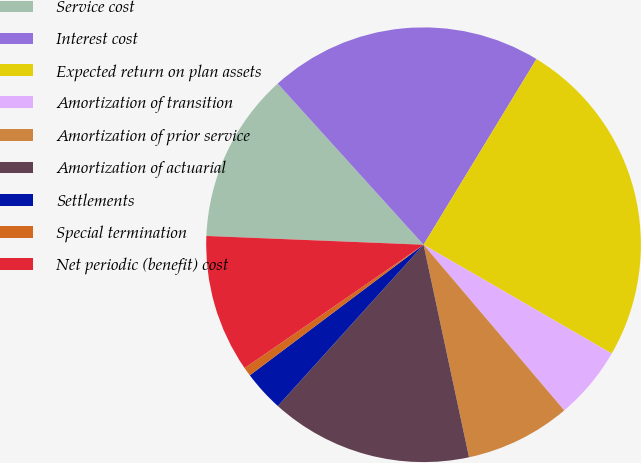Convert chart to OTSL. <chart><loc_0><loc_0><loc_500><loc_500><pie_chart><fcel>Service cost<fcel>Interest cost<fcel>Expected return on plan assets<fcel>Amortization of transition<fcel>Amortization of prior service<fcel>Amortization of actuarial<fcel>Settlements<fcel>Special termination<fcel>Net periodic (benefit) cost<nl><fcel>12.65%<fcel>20.4%<fcel>24.65%<fcel>5.45%<fcel>7.85%<fcel>15.05%<fcel>3.05%<fcel>0.65%<fcel>10.25%<nl></chart> 